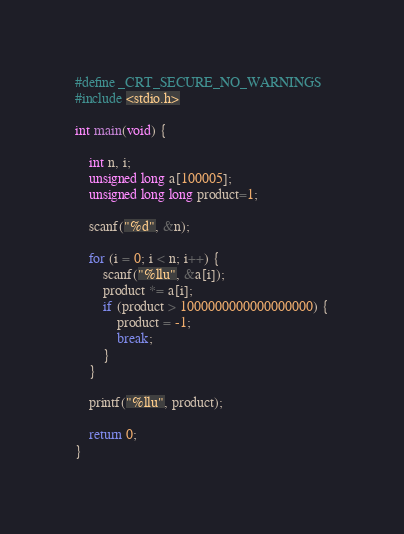<code> <loc_0><loc_0><loc_500><loc_500><_C_>#define _CRT_SECURE_NO_WARNINGS
#include <stdio.h>

int main(void) {

	int n, i;
	unsigned long a[100005];
	unsigned long long product=1;

	scanf("%d", &n);

	for (i = 0; i < n; i++) {
		scanf("%llu", &a[i]);
		product *= a[i];
		if (product > 1000000000000000000) {
			product = -1;
			break;
		}
	}

	printf("%llu", product);

	return 0;
}</code> 